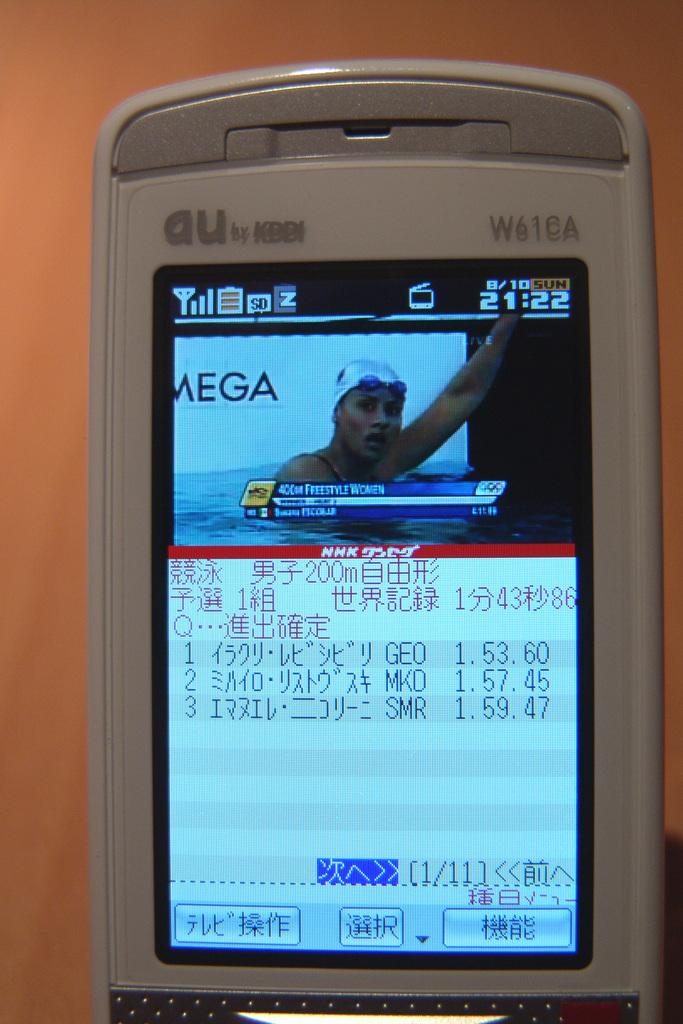What is the main object in the image? There is a mobile in the image. What can be seen on the mobile screen? There is an image on the mobile screen. Are there any other elements visible on the mobile screen? Yes, there are other things visible on the mobile screen. What type of paper can be seen blowing in the wind on the coast in the image? There is no paper blowing in the wind on the coast in the image. Additionally, there is no mention of a coast or a kettle in the provided facts. 